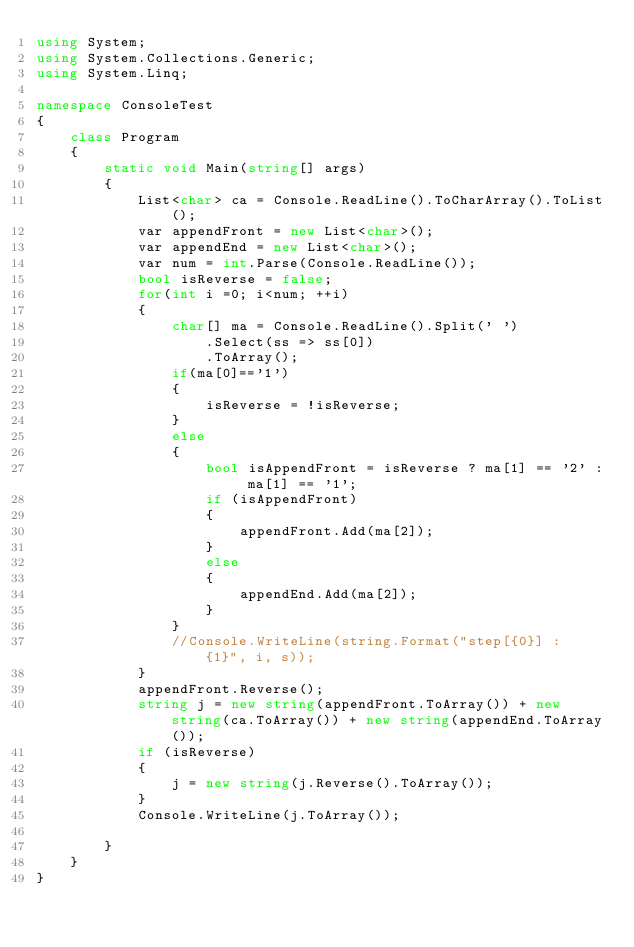<code> <loc_0><loc_0><loc_500><loc_500><_C#_>using System;
using System.Collections.Generic;
using System.Linq;

namespace ConsoleTest
{
    class Program
    {
        static void Main(string[] args)
        {
            List<char> ca = Console.ReadLine().ToCharArray().ToList();
            var appendFront = new List<char>();
            var appendEnd = new List<char>();
            var num = int.Parse(Console.ReadLine());
            bool isReverse = false;
            for(int i =0; i<num; ++i)
            {
                char[] ma = Console.ReadLine().Split(' ')
                    .Select(ss => ss[0])
                    .ToArray();
                if(ma[0]=='1')
                {
                    isReverse = !isReverse;
                }
                else
                {
                    bool isAppendFront = isReverse ? ma[1] == '2' : ma[1] == '1';
                    if (isAppendFront)
                    {
                        appendFront.Add(ma[2]);
                    }
                    else
                    {
                        appendEnd.Add(ma[2]);
                    }
                }
                //Console.WriteLine(string.Format("step[{0}] : {1}", i, s));
            }
            appendFront.Reverse();
            string j = new string(appendFront.ToArray()) + new string(ca.ToArray()) + new string(appendEnd.ToArray());
            if (isReverse)
            {
                j = new string(j.Reverse().ToArray());
            }
            Console.WriteLine(j.ToArray());

        }
    }
}
</code> 